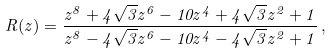<formula> <loc_0><loc_0><loc_500><loc_500>R ( z ) = \frac { z ^ { 8 } + 4 \sqrt { 3 } z ^ { 6 } - 1 0 z ^ { 4 } + 4 \sqrt { 3 } z ^ { 2 } + 1 } { z ^ { 8 } - 4 \sqrt { 3 } z ^ { 6 } - 1 0 z ^ { 4 } - 4 \sqrt { 3 } z ^ { 2 } + 1 } \, ,</formula> 